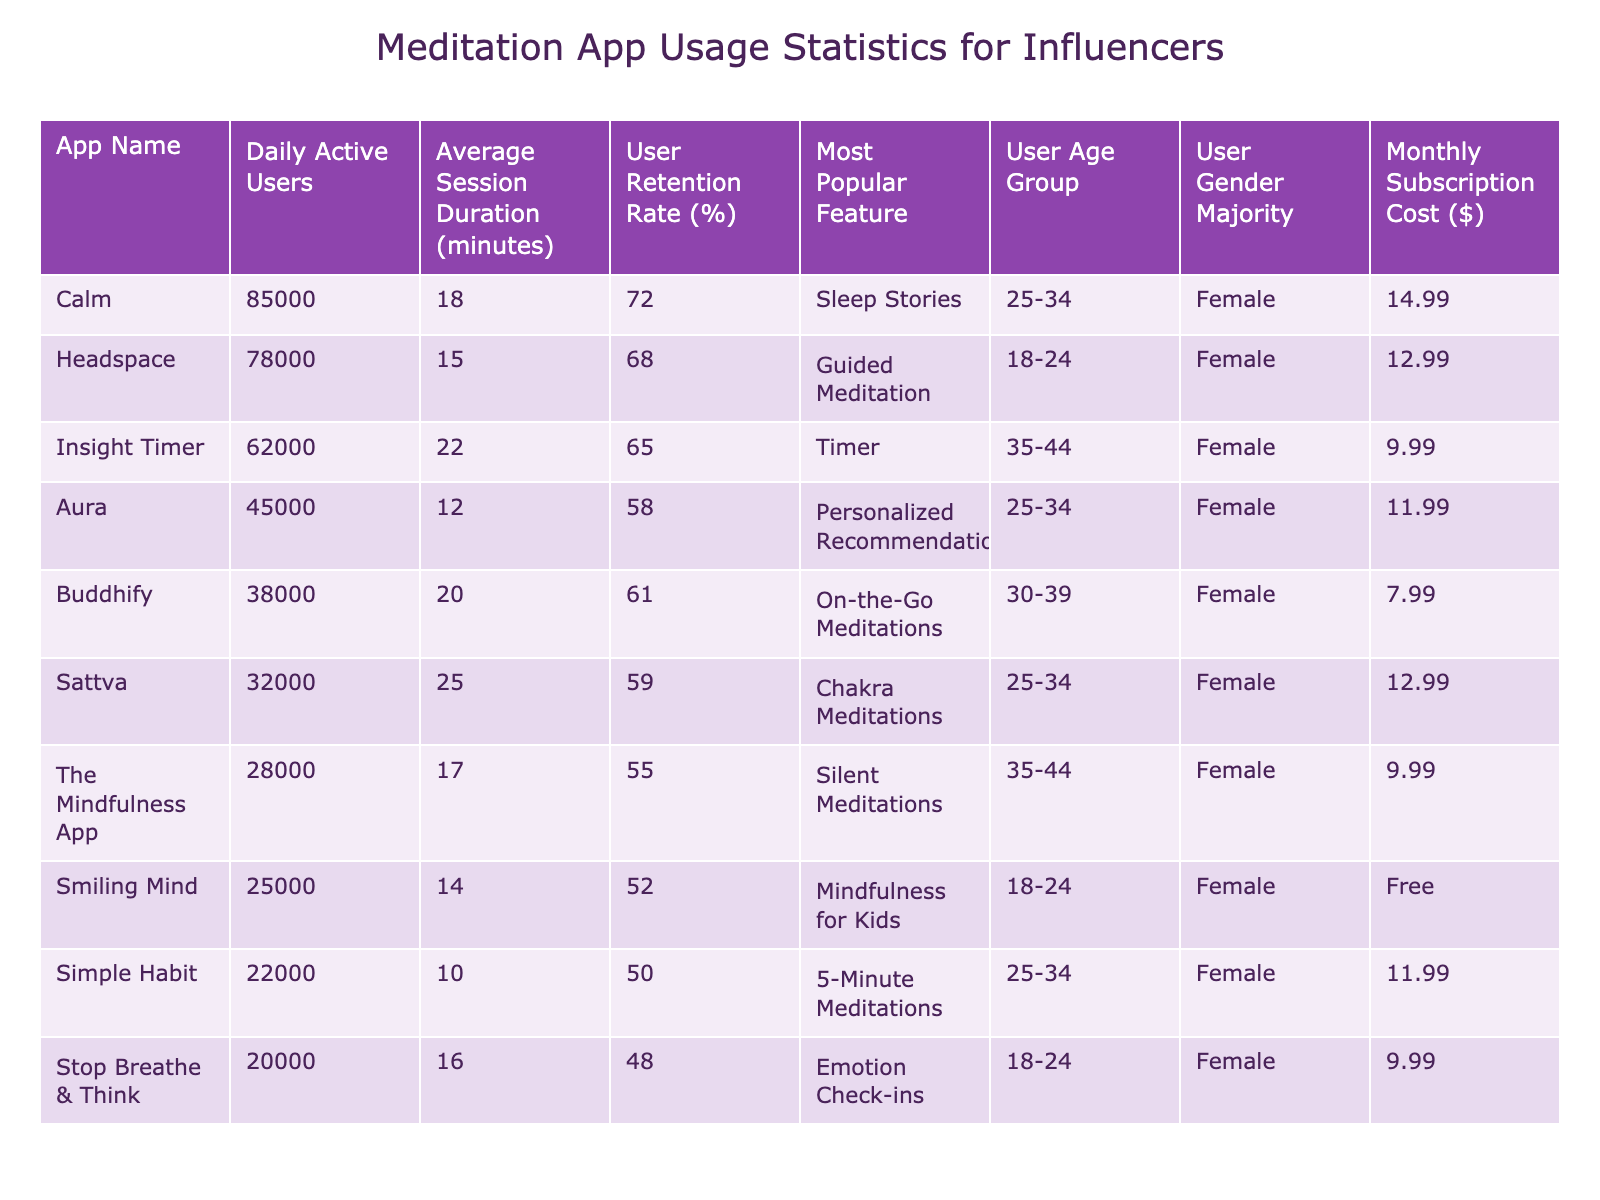What is the most popular feature in the Calm app? By referring to the table under the "Most Popular Feature" column for the Calm app, we can see that it is "Sleep Stories."
Answer: Sleep Stories Which app has the highest Daily Active Users? By looking at the "Daily Active Users" column, Calm has 85,000 users, which is the highest compared to others.
Answer: Calm What is the average session duration for Insight Timer? The table states the average session duration for Insight Timer is 22 minutes, as listed in the respective column.
Answer: 22 minutes Is the user retention rate higher for Headspace than for Buddhify? Checking the "User Retention Rate" column, Headspace has a rate of 68%, while Buddhify has a rate of 61%. Since 68% is greater than 61%, the answer is yes.
Answer: Yes What is the total Daily Active Users for the apps targeting the 25-34 age group? First, identify the apps targeting the 25-34 age range, which are Calm, Aura, Sattva, and Simple Habit. Their users are 85,000, 45,000, 32,000, and 22,000, respectively. Adding them up: 85,000 + 45,000 + 32,000 + 22,000 = 184,000.
Answer: 184,000 Which app has the lowest Monthly Subscription Cost? Looking at the "Monthly Subscription Cost" column, Smiling Mind is listed as Free, which is the lowest indicating that it has no subscription cost.
Answer: Free What percentage of apps have a retention rate over 60%? Checking the "User Retention Rate" column, the apps with a rate over 60% are Calm (72%), Headspace (68%), and Buddhify (61%). There are 3 such apps out of a total of 10 apps: (3/10) * 100 = 30%.
Answer: 30% How many apps have a session duration greater than 20 minutes? We can check the "Average Session Duration" column and count those greater than 20 minutes: Insight Timer (22), Sattva (25), and Buddhify (20). This gives us a total of 3 apps.
Answer: 3 What is the difference in Daily Active Users between Calm and the Mindfulness App? The Daily Active Users for Calm is 85,000, and for The Mindfulness App, it is 28,000. The difference is calculated as 85,000 - 28,000 = 57,000.
Answer: 57,000 Are there more users in the 18-24 age group than in the 35-44 age group across all apps? The apps in the 18-24 age group are Headspace (78,000) and Stop Breathe & Think (20,000), totaling 98,000. The apps in the 35-44 age group are Insight Timer (62,000) and The Mindfulness App (28,000), totaling 90,000. Since 98,000 is greater than 90,000, the answer is yes.
Answer: Yes 